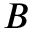Convert formula to latex. <formula><loc_0><loc_0><loc_500><loc_500>B</formula> 